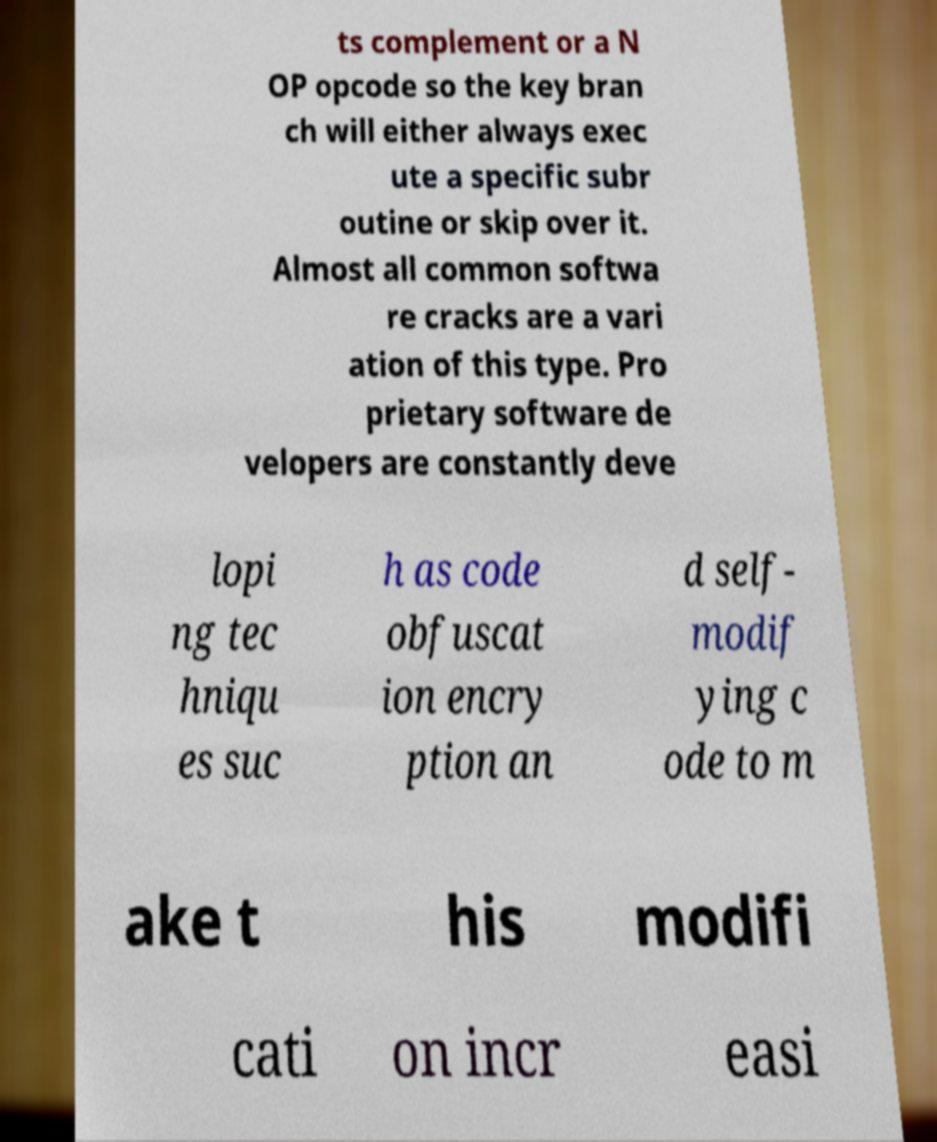For documentation purposes, I need the text within this image transcribed. Could you provide that? ts complement or a N OP opcode so the key bran ch will either always exec ute a specific subr outine or skip over it. Almost all common softwa re cracks are a vari ation of this type. Pro prietary software de velopers are constantly deve lopi ng tec hniqu es suc h as code obfuscat ion encry ption an d self- modif ying c ode to m ake t his modifi cati on incr easi 